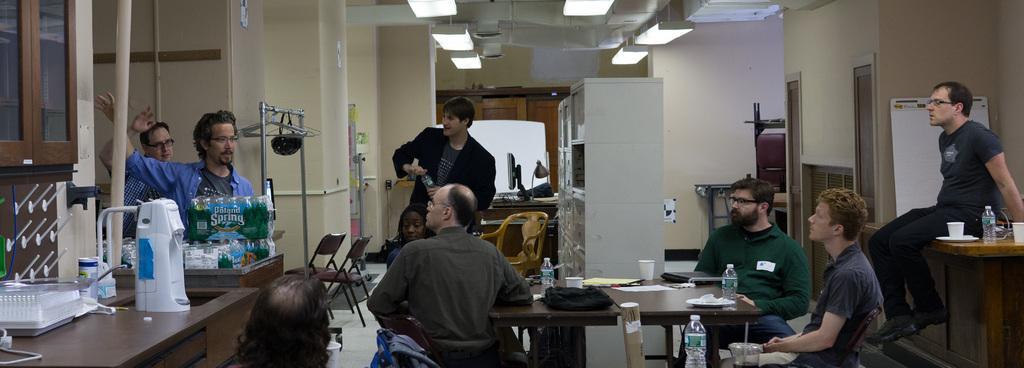How would you summarize this image in a sentence or two? Here we can see a group of people sitting on chairs here and there are some people standing and we can see tables present here and there with bottles of water and cups present and we can see some things present on the left side and we can see lights at the top present 